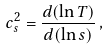Convert formula to latex. <formula><loc_0><loc_0><loc_500><loc_500>c _ { s } ^ { 2 } = \frac { d ( \ln T ) } { d ( \ln s ) } \, ,</formula> 